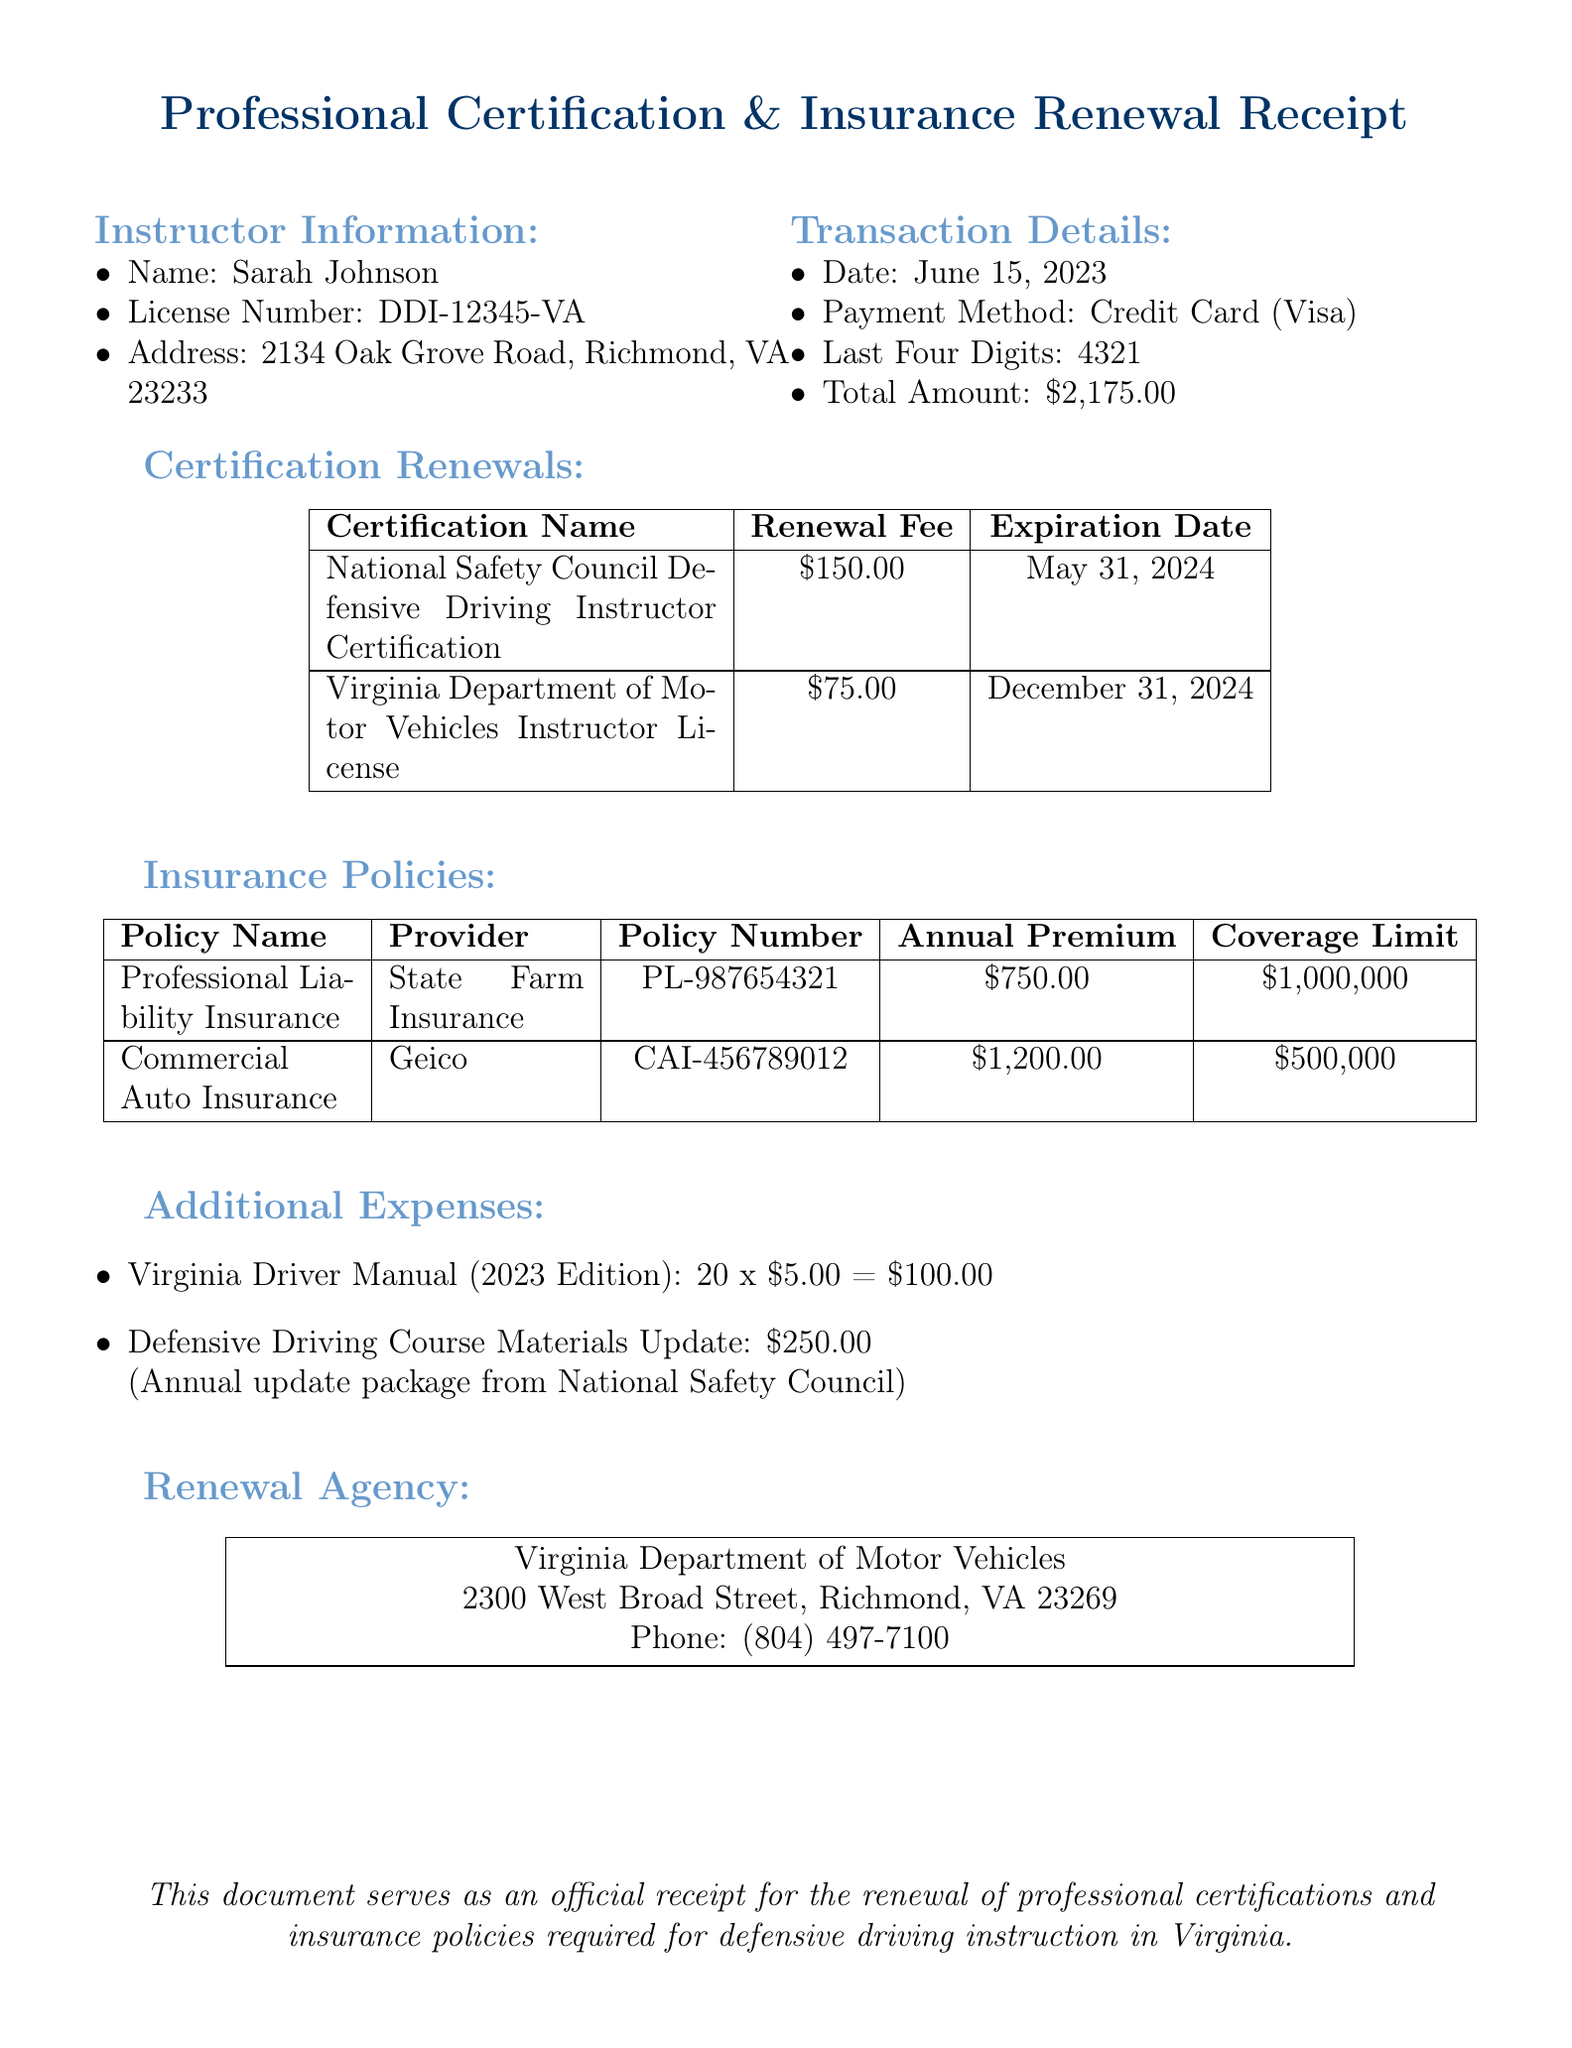What is the instructor's name? The instructor's name is explicitly listed in the document under instructor information.
Answer: Sarah Johnson What is the renewal fee for the National Safety Council Defensive Driving Instructor Certification? The renewal fee for this certification is specified in the certification renewals section of the document.
Answer: $150.00 What is the expiration date of the Virginia Department of Motor Vehicles Instructor License? This expiration date is detailed in the certification renewals section, which lists all certification expiration dates.
Answer: December 31, 2024 What is the total amount paid for the renewals and expenses? The total amount is provided in the transaction details portion of the document as the completion of the financial transactions.
Answer: $2,175.00 How many Virginia Driver Manuals were purchased? The quantity purchased is detailed in the additional expenses section of the document.
Answer: 20 What is the name of the provider for the Professional Liability Insurance? The provider's name is clearly stated in the insurance policies section of the document.
Answer: State Farm Insurance What is the coverage limit for the Commercial Auto Insurance? This coverage limit is specified in the insurance policies section of the document.
Answer: $500,000 What is the date of the transaction? The date of the transaction is outlined in the transaction details section of the document.
Answer: June 15, 2023 What agency is involved in the renewal process? The agency responsible for the renewal is detailed under the renewal agency section in the document.
Answer: Virginia Department of Motor Vehicles 